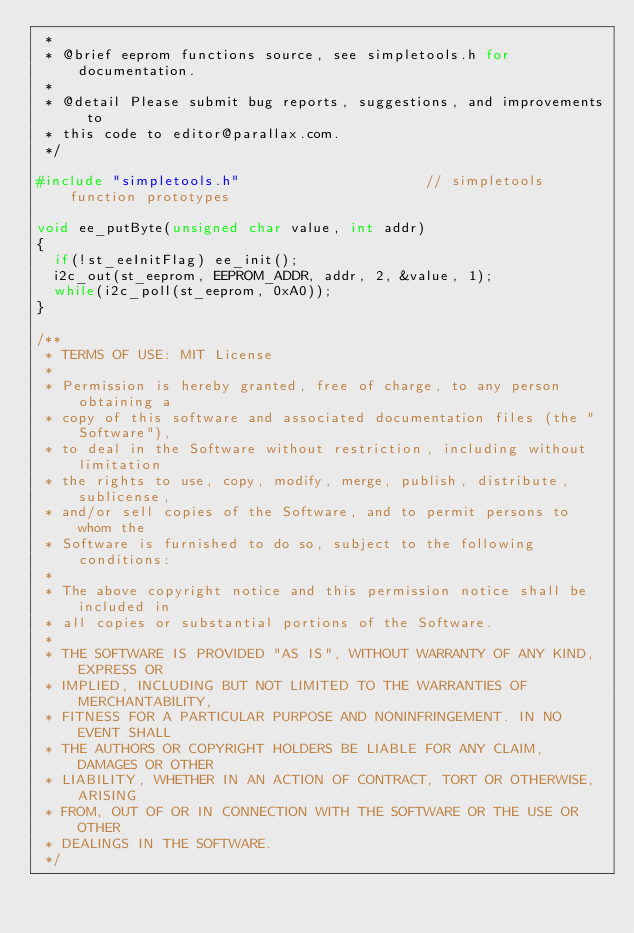Convert code to text. <code><loc_0><loc_0><loc_500><loc_500><_C_> *
 * @brief eeprom functions source, see simpletools.h for documentation.
 *
 * @detail Please submit bug reports, suggestions, and improvements to
 * this code to editor@parallax.com.
 */

#include "simpletools.h"                      // simpletools function prototypes

void ee_putByte(unsigned char value, int addr)
{
  if(!st_eeInitFlag) ee_init();
  i2c_out(st_eeprom, EEPROM_ADDR, addr, 2, &value, 1);
  while(i2c_poll(st_eeprom, 0xA0)); 
}

/**
 * TERMS OF USE: MIT License
 *
 * Permission is hereby granted, free of charge, to any person obtaining a
 * copy of this software and associated documentation files (the "Software"),
 * to deal in the Software without restriction, including without limitation
 * the rights to use, copy, modify, merge, publish, distribute, sublicense,
 * and/or sell copies of the Software, and to permit persons to whom the
 * Software is furnished to do so, subject to the following conditions:
 *
 * The above copyright notice and this permission notice shall be included in
 * all copies or substantial portions of the Software.
 *
 * THE SOFTWARE IS PROVIDED "AS IS", WITHOUT WARRANTY OF ANY KIND, EXPRESS OR
 * IMPLIED, INCLUDING BUT NOT LIMITED TO THE WARRANTIES OF MERCHANTABILITY,
 * FITNESS FOR A PARTICULAR PURPOSE AND NONINFRINGEMENT. IN NO EVENT SHALL
 * THE AUTHORS OR COPYRIGHT HOLDERS BE LIABLE FOR ANY CLAIM, DAMAGES OR OTHER
 * LIABILITY, WHETHER IN AN ACTION OF CONTRACT, TORT OR OTHERWISE, ARISING
 * FROM, OUT OF OR IN CONNECTION WITH THE SOFTWARE OR THE USE OR OTHER
 * DEALINGS IN THE SOFTWARE.
 */
</code> 